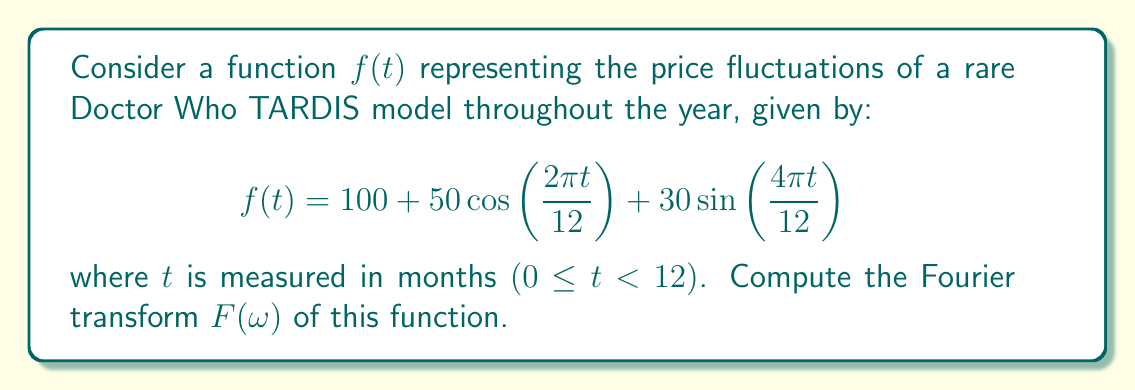Can you answer this question? To compute the Fourier transform of $f(t)$, we'll use the definition:

$$F(\omega) = \int_{-\infty}^{\infty} f(t) e^{-i\omega t} dt$$

Let's break down $f(t)$ into its components:

1. Constant term: $100$
2. Cosine term: $50\cos\left(\frac{2\pi t}{12}\right)$
3. Sine term: $30\sin\left(\frac{4\pi t}{12}\right)$

For the constant term:
$$\mathcal{F}\{100\} = 100 \cdot 2\pi\delta(\omega)$$

For the cosine term, we use the Fourier transform property:
$$\mathcal{F}\{A\cos(at)\} = \pi A[\delta(\omega-a) + \delta(\omega+a)]$$
Here, $A=50$ and $a=\frac{2\pi}{12}=\frac{\pi}{6}$
$$\mathcal{F}\{50\cos\left(\frac{2\pi t}{12}\right)\} = 50\pi[\delta(\omega-\frac{\pi}{6}) + \delta(\omega+\frac{\pi}{6})]$$

For the sine term, we use:
$$\mathcal{F}\{A\sin(at)\} = i\pi A[\delta(\omega-a) - \delta(\omega+a)]$$
Here, $A=30$ and $a=\frac{4\pi}{12}=\frac{\pi}{3}$
$$\mathcal{F}\{30\sin\left(\frac{4\pi t}{12}\right)\} = 30i\pi[\delta(\omega-\frac{\pi}{3}) - \delta(\omega+\frac{\pi}{3})]$$

Combining all terms:

$$F(\omega) = 200\pi\delta(\omega) + 50\pi[\delta(\omega-\frac{\pi}{6}) + \delta(\omega+\frac{\pi}{6})] + 30i\pi[\delta(\omega-\frac{\pi}{3}) - \delta(\omega+\frac{\pi}{3})]$$
Answer: $$F(\omega) = 200\pi\delta(\omega) + 50\pi[\delta(\omega-\frac{\pi}{6}) + \delta(\omega+\frac{\pi}{6})] + 30i\pi[\delta(\omega-\frac{\pi}{3}) - \delta(\omega+\frac{\pi}{3})]$$ 